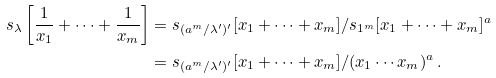<formula> <loc_0><loc_0><loc_500><loc_500>s _ { \lambda } \left [ \frac { 1 } { x _ { 1 } } + \cdots + \frac { 1 } { x _ { m } } \right ] & = s _ { ( a ^ { m } / \lambda ^ { \prime } ) ^ { \prime } } [ x _ { 1 } + \cdots + x _ { m } ] / s _ { 1 ^ { m } } [ x _ { 1 } + \cdots + x _ { m } ] ^ { a } \\ & = s _ { ( a ^ { m } / \lambda ^ { \prime } ) ^ { \prime } } [ x _ { 1 } + \cdots + x _ { m } ] / ( x _ { 1 } \cdots x _ { m } ) ^ { a } \, .</formula> 